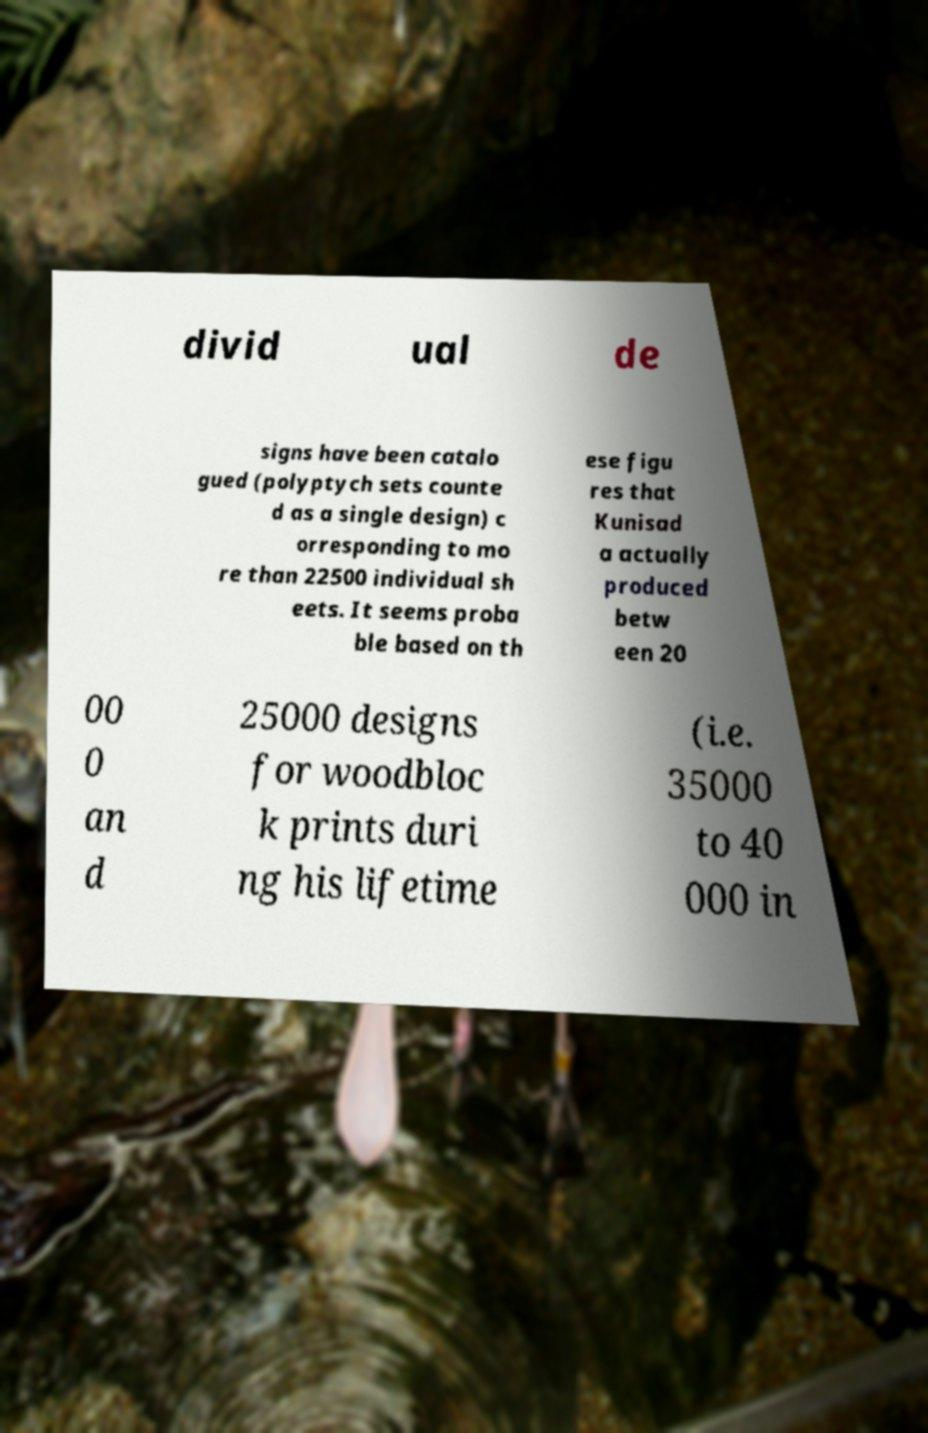Please identify and transcribe the text found in this image. divid ual de signs have been catalo gued (polyptych sets counte d as a single design) c orresponding to mo re than 22500 individual sh eets. It seems proba ble based on th ese figu res that Kunisad a actually produced betw een 20 00 0 an d 25000 designs for woodbloc k prints duri ng his lifetime (i.e. 35000 to 40 000 in 